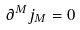Convert formula to latex. <formula><loc_0><loc_0><loc_500><loc_500>\partial ^ { M } j _ { M } = 0</formula> 